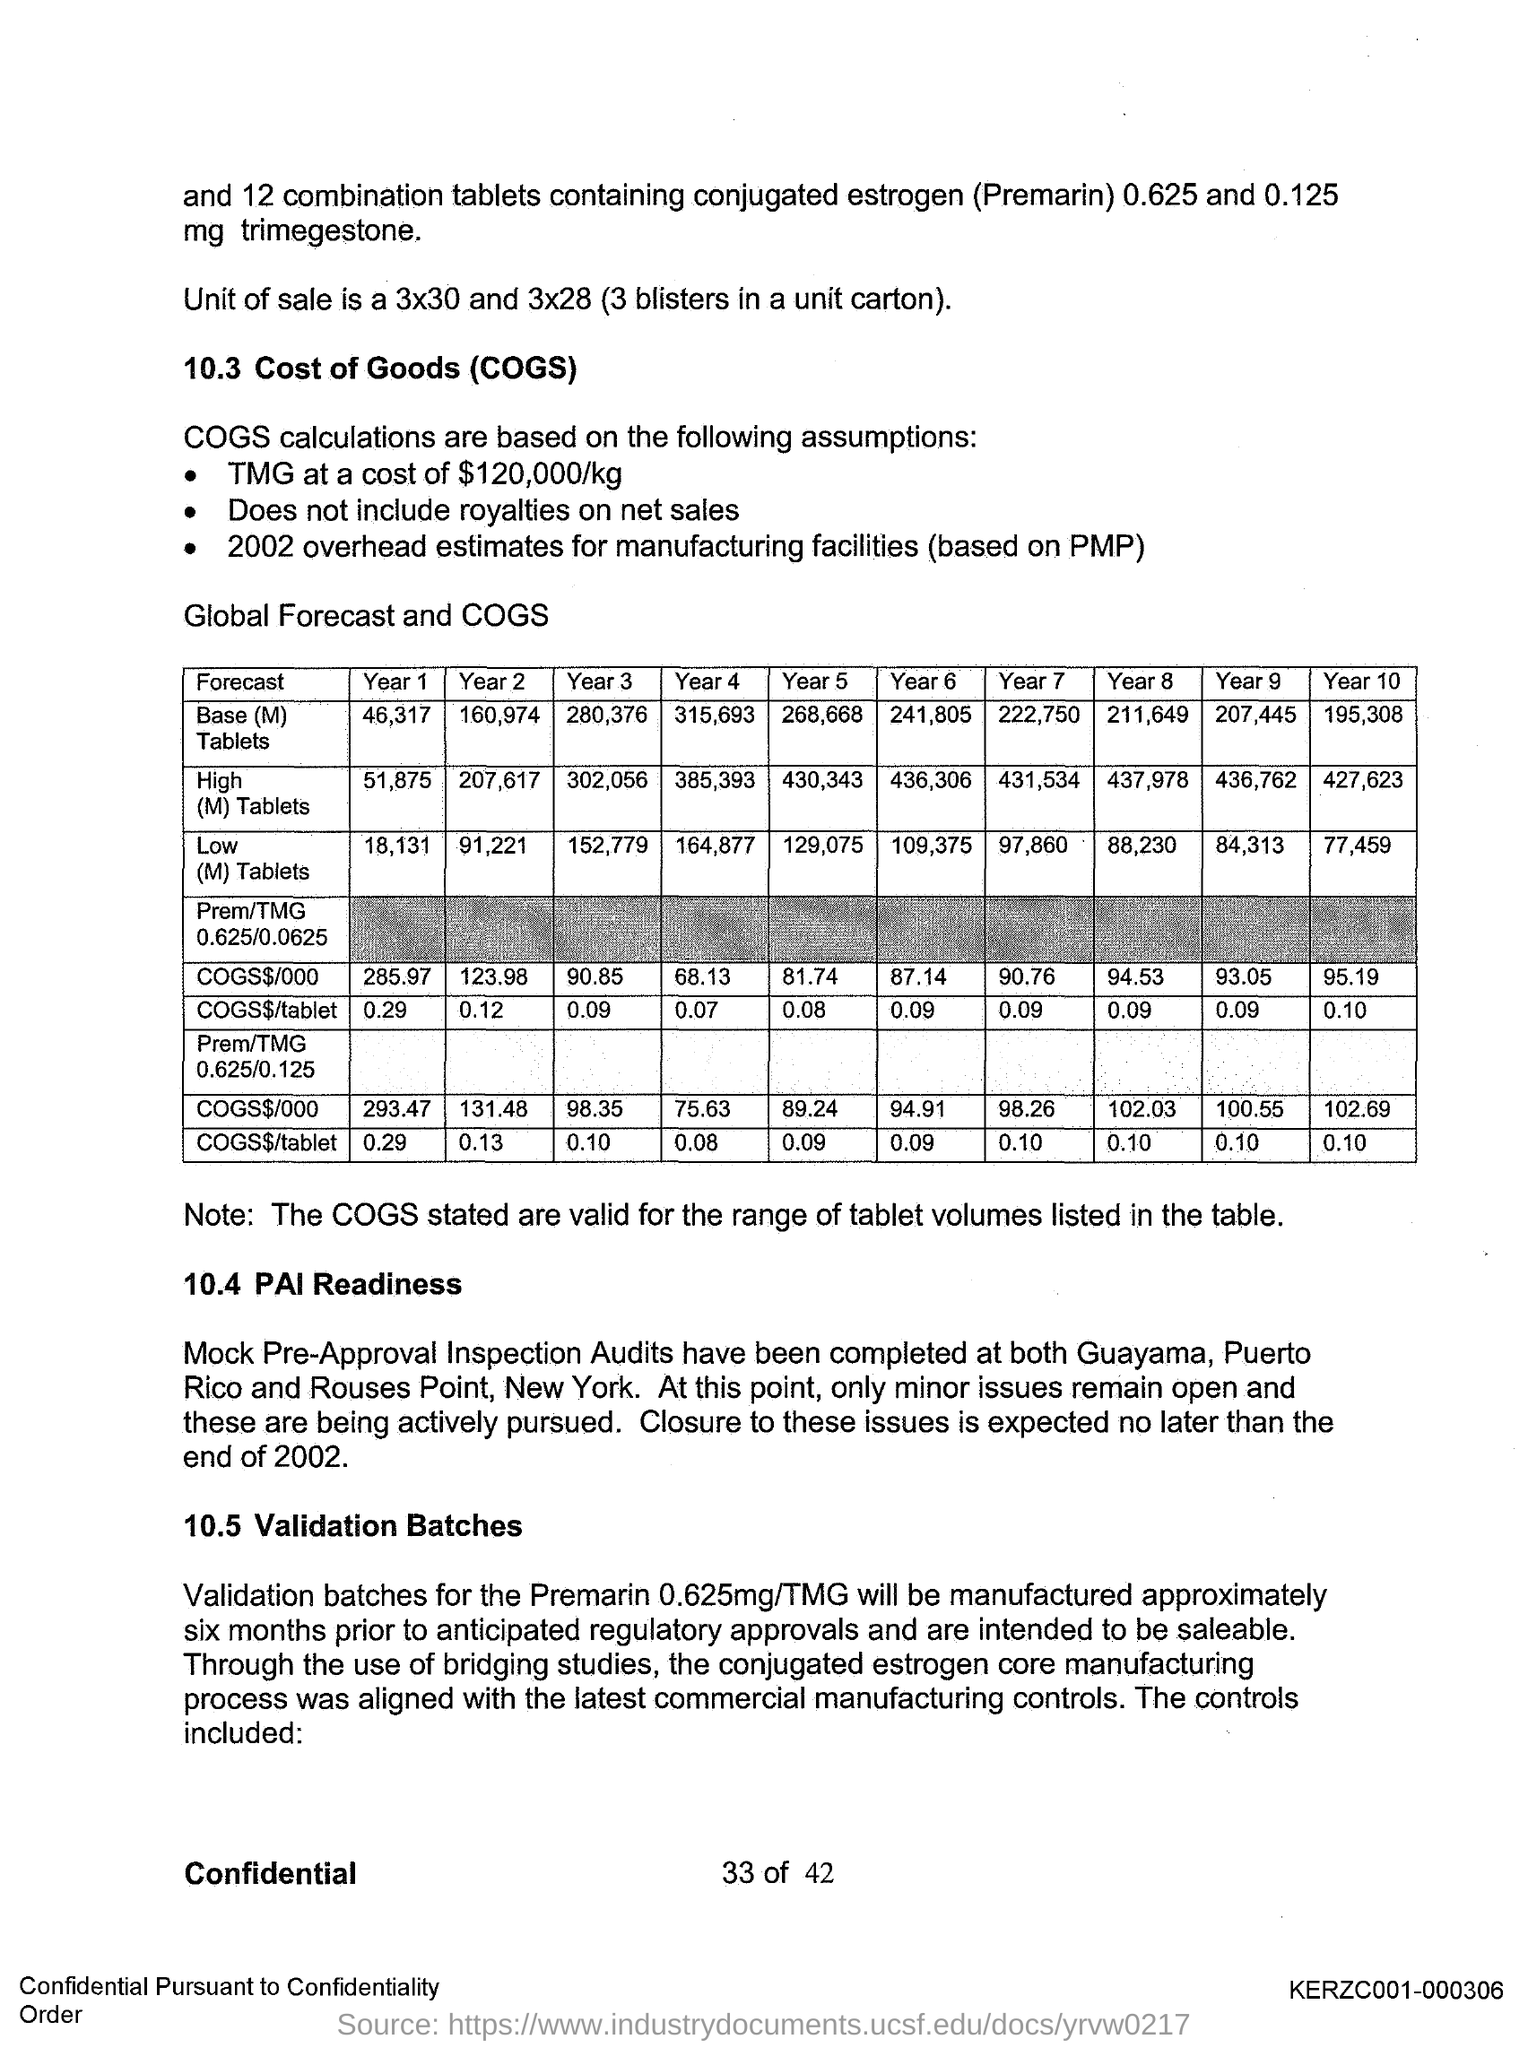Mention a couple of crucial points in this snapshot. The full form of COGS is Cost of Goods Sold. Pre-Approval Inspection (PAI) is the full form of the term. 